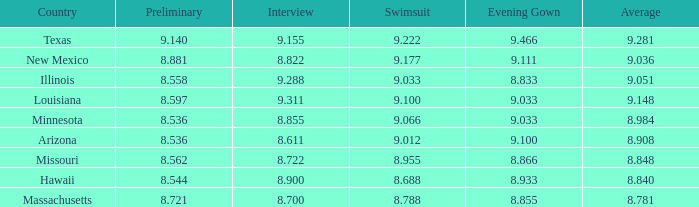What was the swimsuit score for Illinois? 9.033. 